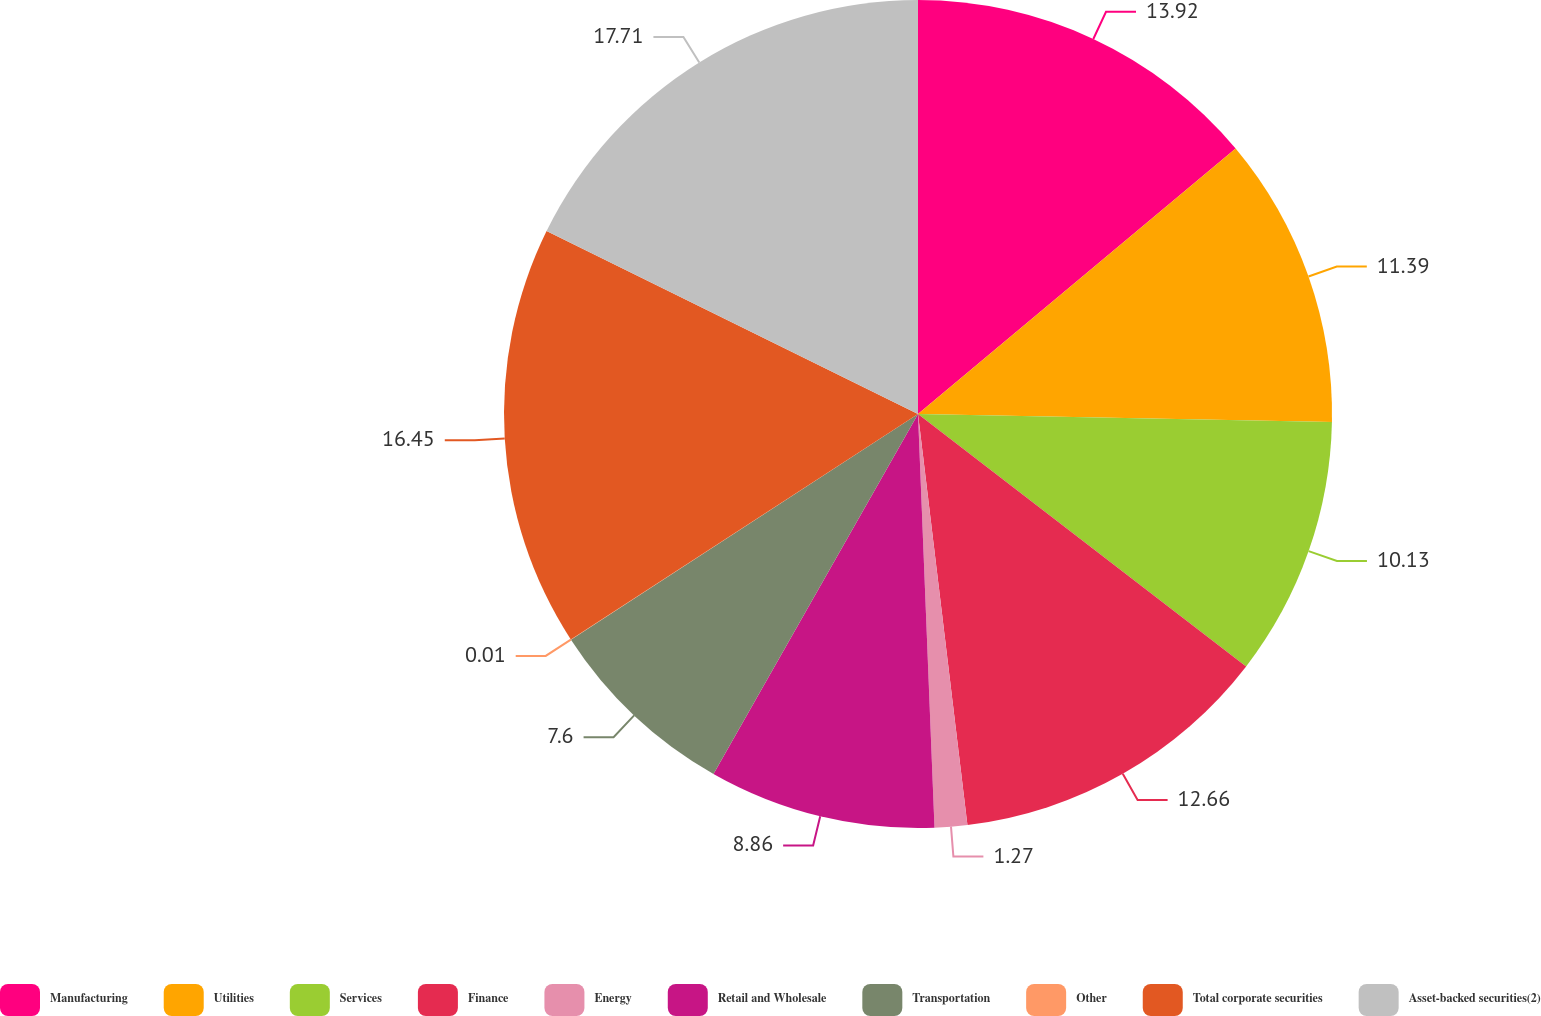<chart> <loc_0><loc_0><loc_500><loc_500><pie_chart><fcel>Manufacturing<fcel>Utilities<fcel>Services<fcel>Finance<fcel>Energy<fcel>Retail and Wholesale<fcel>Transportation<fcel>Other<fcel>Total corporate securities<fcel>Asset-backed securities(2)<nl><fcel>13.92%<fcel>11.39%<fcel>10.13%<fcel>12.66%<fcel>1.27%<fcel>8.86%<fcel>7.6%<fcel>0.01%<fcel>16.45%<fcel>17.72%<nl></chart> 